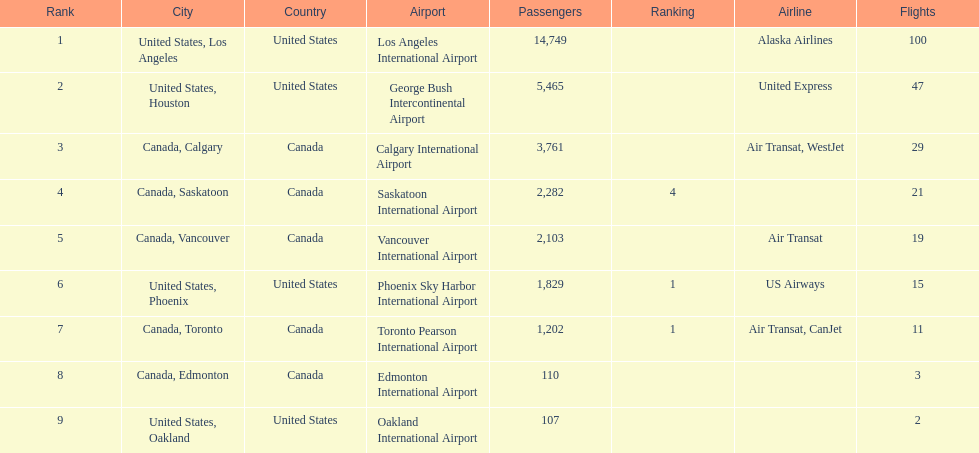What numbers are in the passengers column? 14,749, 5,465, 3,761, 2,282, 2,103, 1,829, 1,202, 110, 107. Which number is the lowest number in the passengers column? 107. What city is associated with this number? United States, Oakland. 